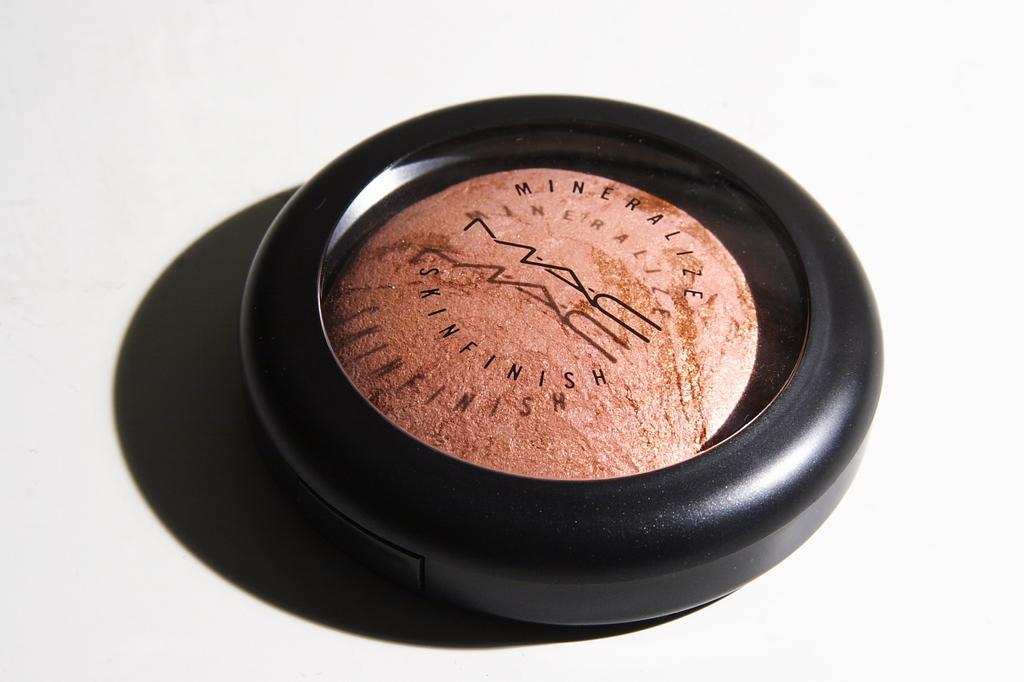<image>
Create a compact narrative representing the image presented. A beauty blender that is called Mineralize Skinfinish 